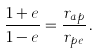<formula> <loc_0><loc_0><loc_500><loc_500>\frac { 1 + e } { 1 - e } = \frac { r _ { a p } } { r _ { p e } } \, .</formula> 